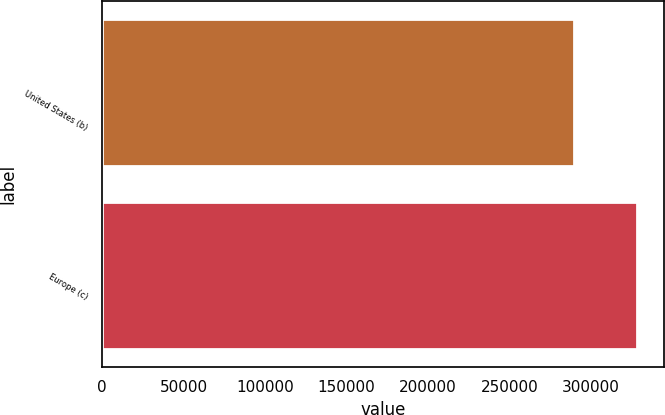<chart> <loc_0><loc_0><loc_500><loc_500><bar_chart><fcel>United States (b)<fcel>Europe (c)<nl><fcel>289875<fcel>328493<nl></chart> 